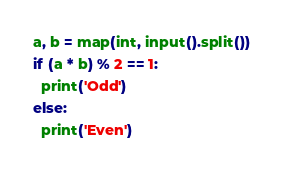<code> <loc_0><loc_0><loc_500><loc_500><_Python_>a, b = map(int, input().split())
if (a * b) % 2 == 1:
  print('Odd')
else:
  print('Even') </code> 